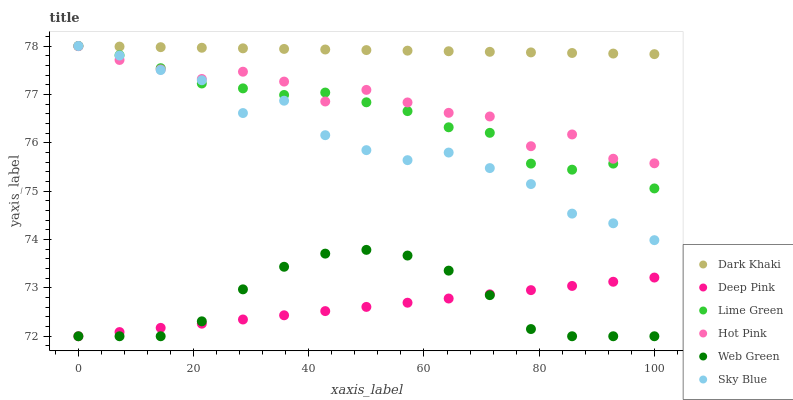Does Deep Pink have the minimum area under the curve?
Answer yes or no. Yes. Does Dark Khaki have the maximum area under the curve?
Answer yes or no. Yes. Does Hot Pink have the minimum area under the curve?
Answer yes or no. No. Does Hot Pink have the maximum area under the curve?
Answer yes or no. No. Is Deep Pink the smoothest?
Answer yes or no. Yes. Is Hot Pink the roughest?
Answer yes or no. Yes. Is Web Green the smoothest?
Answer yes or no. No. Is Web Green the roughest?
Answer yes or no. No. Does Deep Pink have the lowest value?
Answer yes or no. Yes. Does Hot Pink have the lowest value?
Answer yes or no. No. Does Lime Green have the highest value?
Answer yes or no. Yes. Does Hot Pink have the highest value?
Answer yes or no. No. Is Web Green less than Dark Khaki?
Answer yes or no. Yes. Is Sky Blue greater than Web Green?
Answer yes or no. Yes. Does Lime Green intersect Sky Blue?
Answer yes or no. Yes. Is Lime Green less than Sky Blue?
Answer yes or no. No. Is Lime Green greater than Sky Blue?
Answer yes or no. No. Does Web Green intersect Dark Khaki?
Answer yes or no. No. 